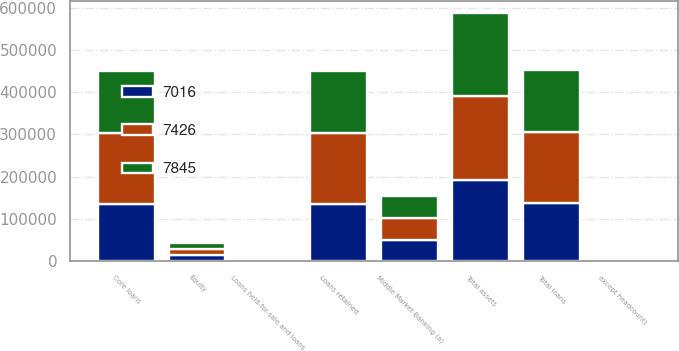Convert chart to OTSL. <chart><loc_0><loc_0><loc_500><loc_500><stacked_bar_chart><ecel><fcel>except headcount)<fcel>Total assets<fcel>Loans retained<fcel>Loans held-for-sale and loans<fcel>Total loans<fcel>Core loans<fcel>Equity<fcel>Middle Market Banking (a)<nl><fcel>7426<fcel>2015<fcel>200700<fcel>167374<fcel>267<fcel>167641<fcel>166939<fcel>14000<fcel>51362<nl><fcel>7845<fcel>2014<fcel>195267<fcel>147661<fcel>845<fcel>148506<fcel>147392<fcel>14000<fcel>51009<nl><fcel>7016<fcel>2013<fcel>190782<fcel>135750<fcel>1388<fcel>137138<fcel>135583<fcel>13500<fcel>50702<nl></chart> 